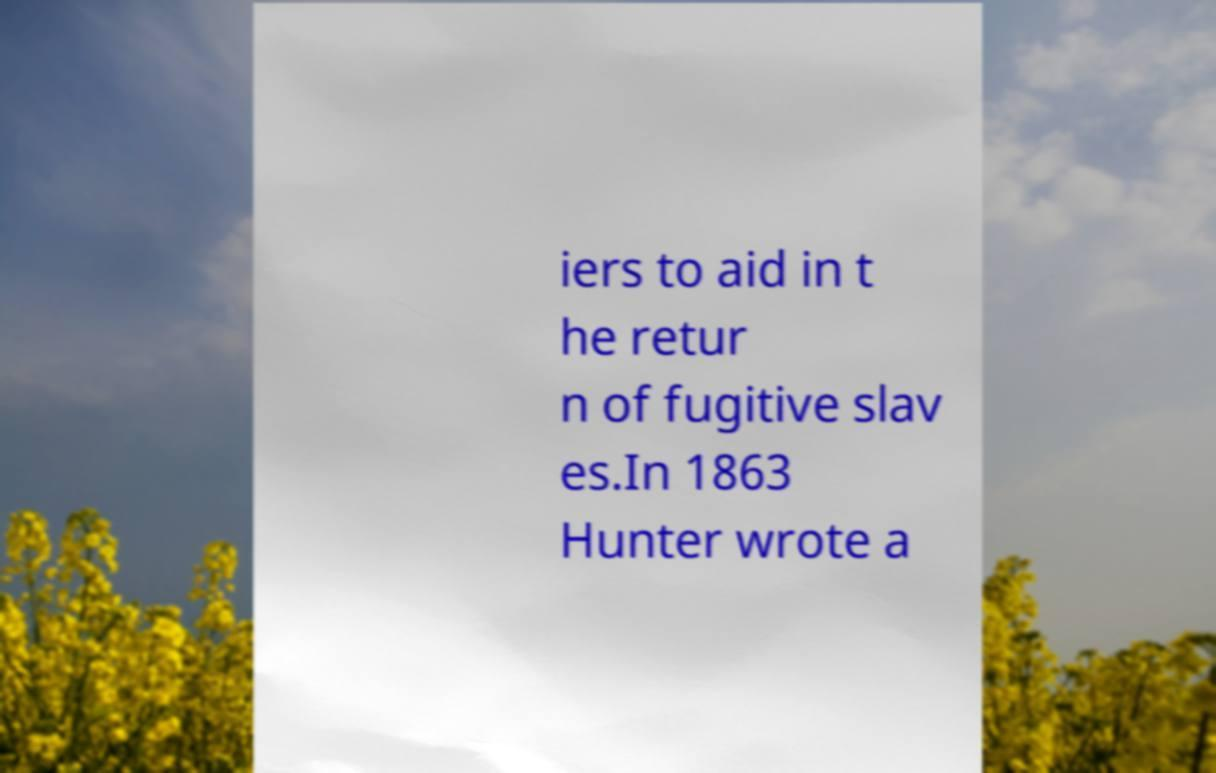I need the written content from this picture converted into text. Can you do that? iers to aid in t he retur n of fugitive slav es.In 1863 Hunter wrote a 